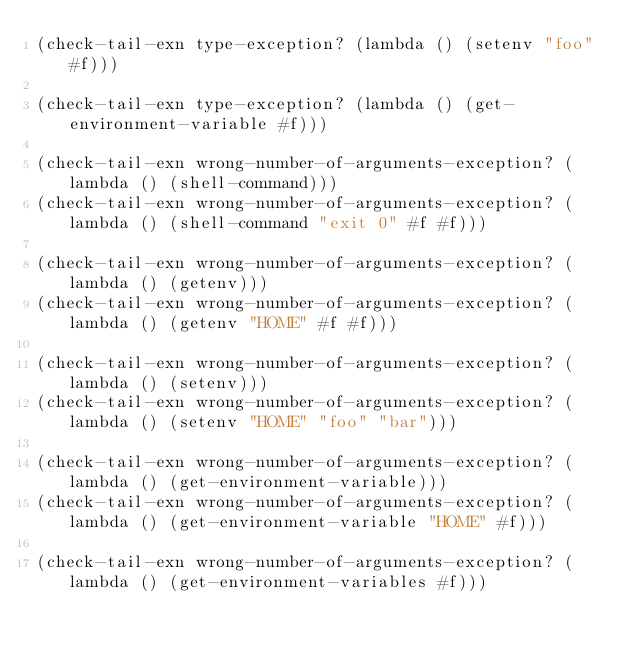Convert code to text. <code><loc_0><loc_0><loc_500><loc_500><_Scheme_>(check-tail-exn type-exception? (lambda () (setenv "foo" #f)))

(check-tail-exn type-exception? (lambda () (get-environment-variable #f)))

(check-tail-exn wrong-number-of-arguments-exception? (lambda () (shell-command)))
(check-tail-exn wrong-number-of-arguments-exception? (lambda () (shell-command "exit 0" #f #f)))

(check-tail-exn wrong-number-of-arguments-exception? (lambda () (getenv)))
(check-tail-exn wrong-number-of-arguments-exception? (lambda () (getenv "HOME" #f #f)))

(check-tail-exn wrong-number-of-arguments-exception? (lambda () (setenv)))
(check-tail-exn wrong-number-of-arguments-exception? (lambda () (setenv "HOME" "foo" "bar")))

(check-tail-exn wrong-number-of-arguments-exception? (lambda () (get-environment-variable)))
(check-tail-exn wrong-number-of-arguments-exception? (lambda () (get-environment-variable "HOME" #f)))

(check-tail-exn wrong-number-of-arguments-exception? (lambda () (get-environment-variables #f)))
</code> 